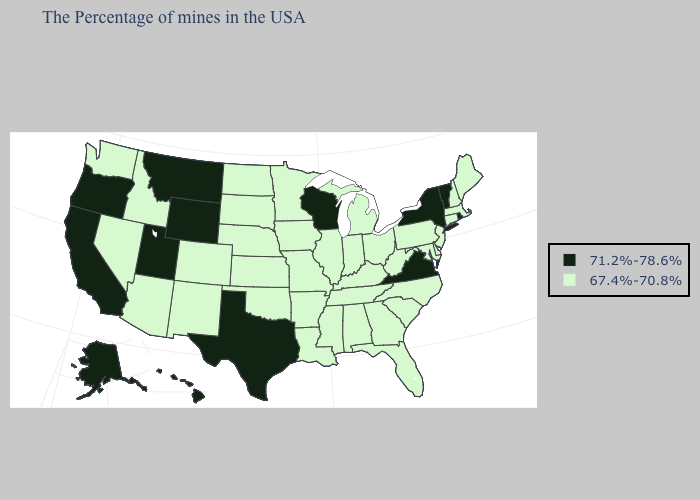Among the states that border Michigan , which have the lowest value?
Keep it brief. Ohio, Indiana. Name the states that have a value in the range 67.4%-70.8%?
Answer briefly. Maine, Massachusetts, New Hampshire, Connecticut, New Jersey, Delaware, Maryland, Pennsylvania, North Carolina, South Carolina, West Virginia, Ohio, Florida, Georgia, Michigan, Kentucky, Indiana, Alabama, Tennessee, Illinois, Mississippi, Louisiana, Missouri, Arkansas, Minnesota, Iowa, Kansas, Nebraska, Oklahoma, South Dakota, North Dakota, Colorado, New Mexico, Arizona, Idaho, Nevada, Washington. Name the states that have a value in the range 67.4%-70.8%?
Short answer required. Maine, Massachusetts, New Hampshire, Connecticut, New Jersey, Delaware, Maryland, Pennsylvania, North Carolina, South Carolina, West Virginia, Ohio, Florida, Georgia, Michigan, Kentucky, Indiana, Alabama, Tennessee, Illinois, Mississippi, Louisiana, Missouri, Arkansas, Minnesota, Iowa, Kansas, Nebraska, Oklahoma, South Dakota, North Dakota, Colorado, New Mexico, Arizona, Idaho, Nevada, Washington. Name the states that have a value in the range 71.2%-78.6%?
Be succinct. Rhode Island, Vermont, New York, Virginia, Wisconsin, Texas, Wyoming, Utah, Montana, California, Oregon, Alaska, Hawaii. What is the highest value in states that border Connecticut?
Be succinct. 71.2%-78.6%. Does the map have missing data?
Concise answer only. No. Does Missouri have a lower value than Louisiana?
Concise answer only. No. What is the highest value in the USA?
Be succinct. 71.2%-78.6%. What is the value of Indiana?
Answer briefly. 67.4%-70.8%. Which states have the lowest value in the MidWest?
Keep it brief. Ohio, Michigan, Indiana, Illinois, Missouri, Minnesota, Iowa, Kansas, Nebraska, South Dakota, North Dakota. What is the value of Nebraska?
Concise answer only. 67.4%-70.8%. Name the states that have a value in the range 67.4%-70.8%?
Concise answer only. Maine, Massachusetts, New Hampshire, Connecticut, New Jersey, Delaware, Maryland, Pennsylvania, North Carolina, South Carolina, West Virginia, Ohio, Florida, Georgia, Michigan, Kentucky, Indiana, Alabama, Tennessee, Illinois, Mississippi, Louisiana, Missouri, Arkansas, Minnesota, Iowa, Kansas, Nebraska, Oklahoma, South Dakota, North Dakota, Colorado, New Mexico, Arizona, Idaho, Nevada, Washington. Does the map have missing data?
Give a very brief answer. No. What is the lowest value in the USA?
Give a very brief answer. 67.4%-70.8%. 